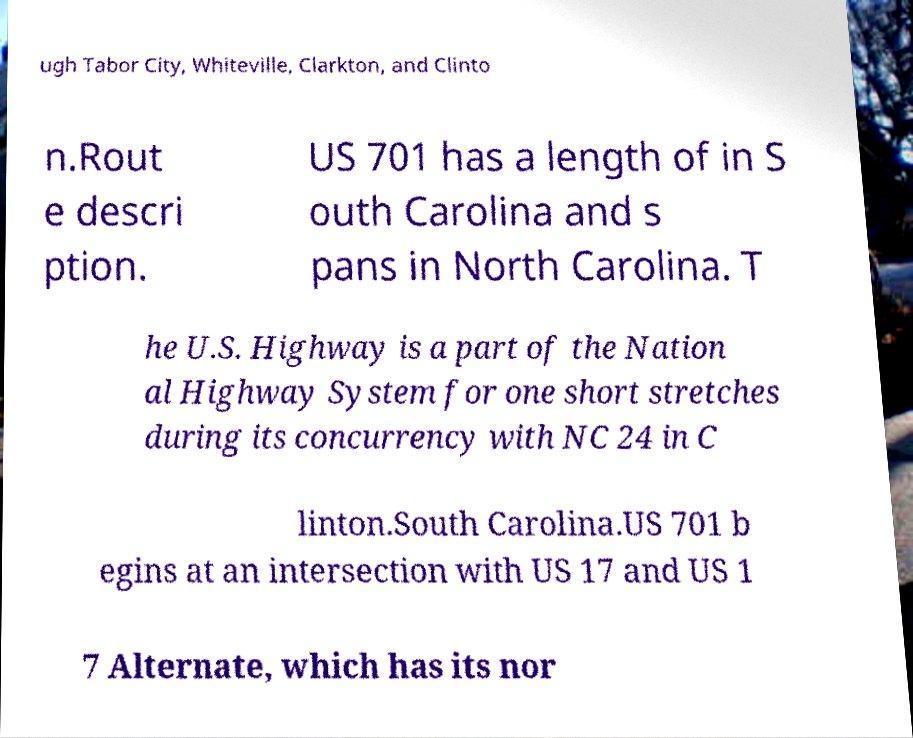What messages or text are displayed in this image? I need them in a readable, typed format. ugh Tabor City, Whiteville, Clarkton, and Clinto n.Rout e descri ption. US 701 has a length of in S outh Carolina and s pans in North Carolina. T he U.S. Highway is a part of the Nation al Highway System for one short stretches during its concurrency with NC 24 in C linton.South Carolina.US 701 b egins at an intersection with US 17 and US 1 7 Alternate, which has its nor 